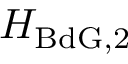Convert formula to latex. <formula><loc_0><loc_0><loc_500><loc_500>H _ { B d G , 2 }</formula> 